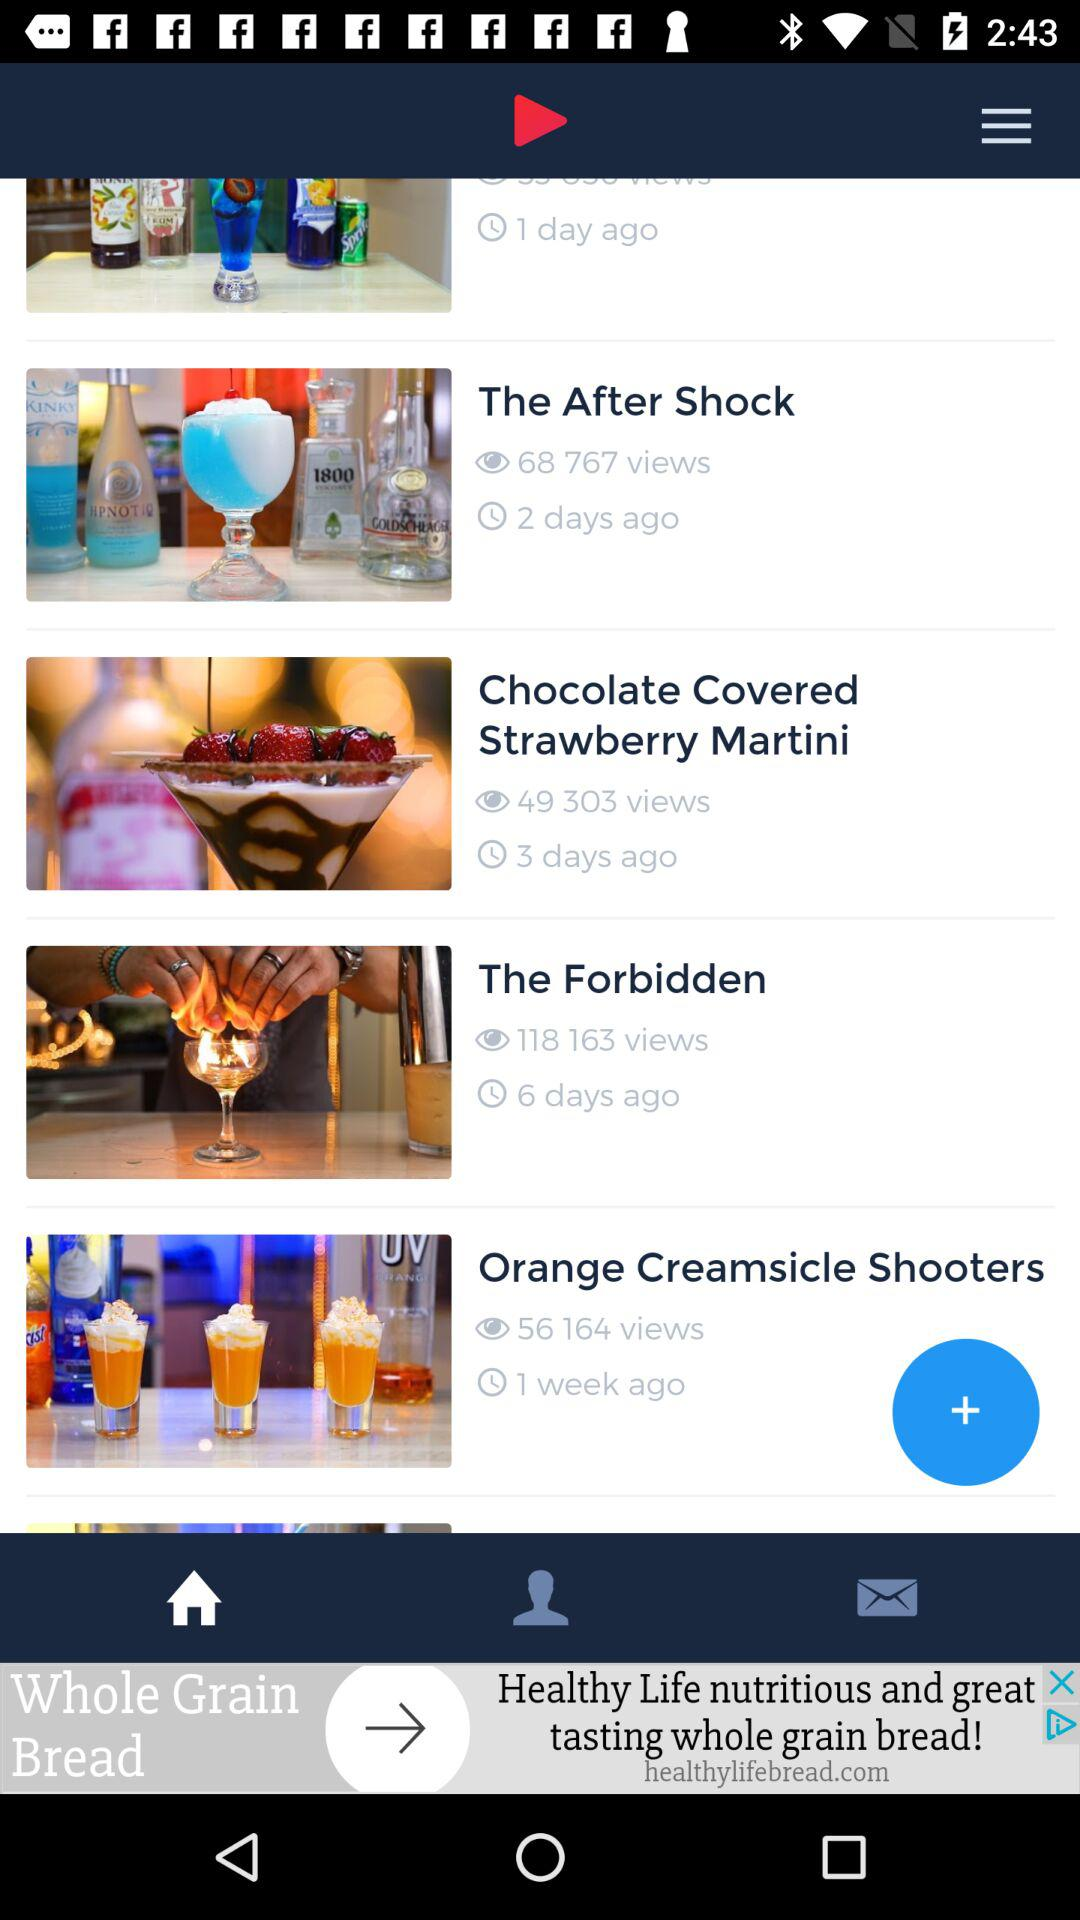How many views did "The Forbidden" get? "The Forbidden" got 118,163 views. 